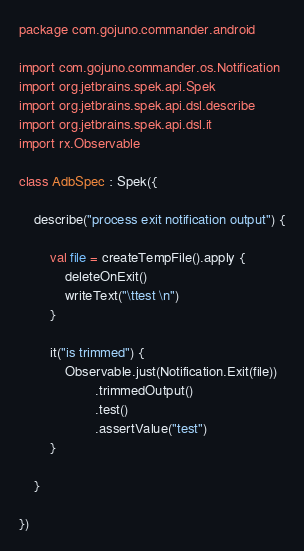<code> <loc_0><loc_0><loc_500><loc_500><_Kotlin_>package com.gojuno.commander.android

import com.gojuno.commander.os.Notification
import org.jetbrains.spek.api.Spek
import org.jetbrains.spek.api.dsl.describe
import org.jetbrains.spek.api.dsl.it
import rx.Observable

class AdbSpec : Spek({

    describe("process exit notification output") {

        val file = createTempFile().apply {
            deleteOnExit()
            writeText("\ttest \n")
        }

        it("is trimmed") {
            Observable.just(Notification.Exit(file))
                    .trimmedOutput()
                    .test()
                    .assertValue("test")
        }

    }

})
</code> 